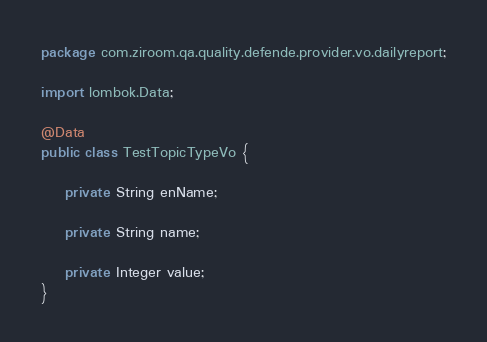Convert code to text. <code><loc_0><loc_0><loc_500><loc_500><_Java_>package com.ziroom.qa.quality.defende.provider.vo.dailyreport;

import lombok.Data;

@Data
public class TestTopicTypeVo {

    private String enName;

    private String name;

    private Integer value;
}
</code> 